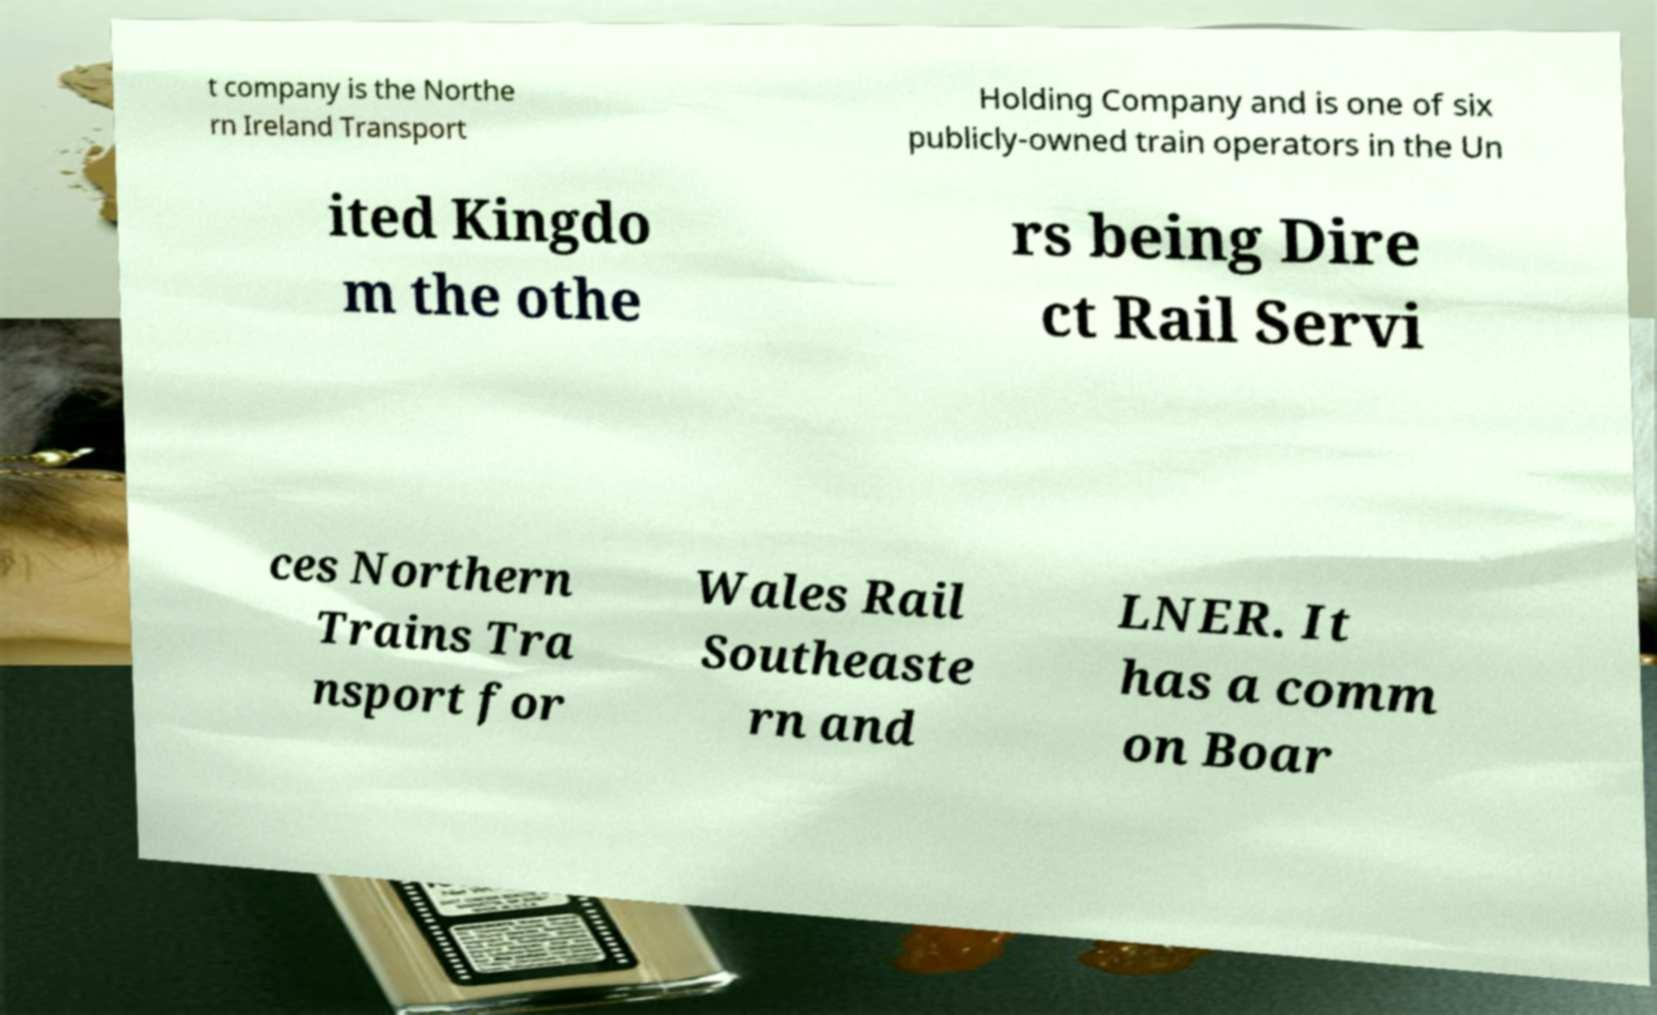Can you read and provide the text displayed in the image?This photo seems to have some interesting text. Can you extract and type it out for me? t company is the Northe rn Ireland Transport Holding Company and is one of six publicly-owned train operators in the Un ited Kingdo m the othe rs being Dire ct Rail Servi ces Northern Trains Tra nsport for Wales Rail Southeaste rn and LNER. It has a comm on Boar 